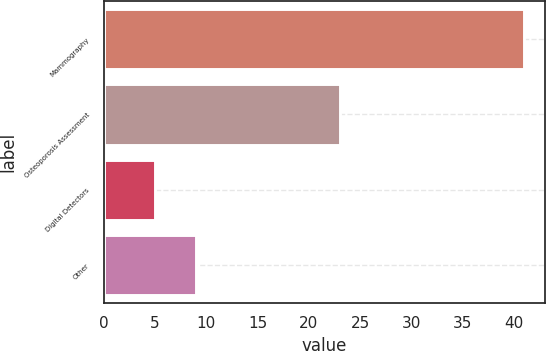<chart> <loc_0><loc_0><loc_500><loc_500><bar_chart><fcel>Mammography<fcel>Osteoporosis Assessment<fcel>Digital Detectors<fcel>Other<nl><fcel>41<fcel>23<fcel>5<fcel>9<nl></chart> 